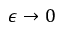<formula> <loc_0><loc_0><loc_500><loc_500>\epsilon \to 0</formula> 